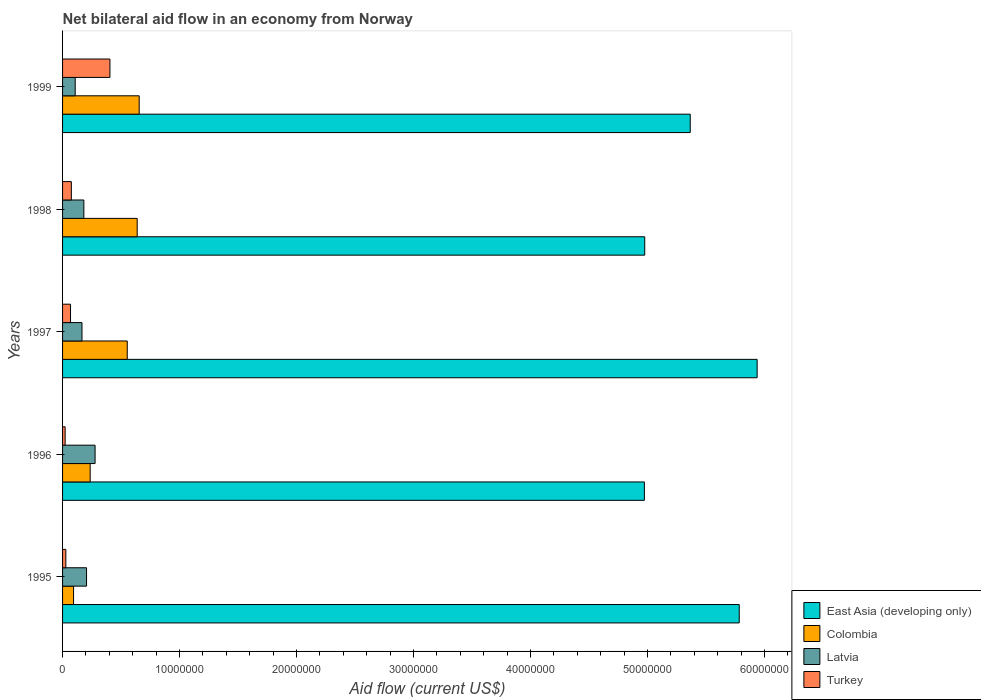How many groups of bars are there?
Make the answer very short. 5. What is the label of the 3rd group of bars from the top?
Provide a short and direct response. 1997. Across all years, what is the maximum net bilateral aid flow in Latvia?
Offer a terse response. 2.78e+06. Across all years, what is the minimum net bilateral aid flow in East Asia (developing only)?
Give a very brief answer. 4.97e+07. In which year was the net bilateral aid flow in Turkey minimum?
Your answer should be very brief. 1996. What is the total net bilateral aid flow in Latvia in the graph?
Your answer should be very brief. 9.39e+06. What is the difference between the net bilateral aid flow in East Asia (developing only) in 1998 and that in 1999?
Offer a very short reply. -3.89e+06. What is the difference between the net bilateral aid flow in Latvia in 1996 and the net bilateral aid flow in Turkey in 1999?
Your answer should be very brief. -1.27e+06. What is the average net bilateral aid flow in Colombia per year?
Provide a succinct answer. 4.35e+06. In the year 1996, what is the difference between the net bilateral aid flow in East Asia (developing only) and net bilateral aid flow in Turkey?
Offer a terse response. 4.95e+07. What is the ratio of the net bilateral aid flow in Latvia in 1996 to that in 1998?
Offer a terse response. 1.53. Is the net bilateral aid flow in Colombia in 1996 less than that in 1997?
Provide a short and direct response. Yes. What is the difference between the highest and the second highest net bilateral aid flow in Colombia?
Provide a short and direct response. 1.70e+05. What is the difference between the highest and the lowest net bilateral aid flow in Colombia?
Offer a terse response. 5.61e+06. In how many years, is the net bilateral aid flow in Colombia greater than the average net bilateral aid flow in Colombia taken over all years?
Offer a terse response. 3. Is it the case that in every year, the sum of the net bilateral aid flow in East Asia (developing only) and net bilateral aid flow in Latvia is greater than the sum of net bilateral aid flow in Turkey and net bilateral aid flow in Colombia?
Give a very brief answer. Yes. What does the 4th bar from the bottom in 1997 represents?
Your answer should be compact. Turkey. How many bars are there?
Your answer should be very brief. 20. What is the difference between two consecutive major ticks on the X-axis?
Ensure brevity in your answer.  1.00e+07. Does the graph contain grids?
Offer a very short reply. No. Where does the legend appear in the graph?
Your answer should be very brief. Bottom right. How are the legend labels stacked?
Your answer should be compact. Vertical. What is the title of the graph?
Your answer should be compact. Net bilateral aid flow in an economy from Norway. Does "United Kingdom" appear as one of the legend labels in the graph?
Provide a short and direct response. No. What is the label or title of the X-axis?
Provide a short and direct response. Aid flow (current US$). What is the Aid flow (current US$) in East Asia (developing only) in 1995?
Give a very brief answer. 5.78e+07. What is the Aid flow (current US$) in Colombia in 1995?
Ensure brevity in your answer.  9.40e+05. What is the Aid flow (current US$) of Latvia in 1995?
Keep it short and to the point. 2.05e+06. What is the Aid flow (current US$) of Turkey in 1995?
Provide a succinct answer. 2.80e+05. What is the Aid flow (current US$) in East Asia (developing only) in 1996?
Offer a very short reply. 4.97e+07. What is the Aid flow (current US$) of Colombia in 1996?
Your answer should be very brief. 2.36e+06. What is the Aid flow (current US$) of Latvia in 1996?
Offer a terse response. 2.78e+06. What is the Aid flow (current US$) in Turkey in 1996?
Your answer should be compact. 2.20e+05. What is the Aid flow (current US$) of East Asia (developing only) in 1997?
Offer a terse response. 5.94e+07. What is the Aid flow (current US$) of Colombia in 1997?
Your answer should be very brief. 5.53e+06. What is the Aid flow (current US$) of Latvia in 1997?
Offer a very short reply. 1.66e+06. What is the Aid flow (current US$) in Turkey in 1997?
Offer a terse response. 6.80e+05. What is the Aid flow (current US$) of East Asia (developing only) in 1998?
Keep it short and to the point. 4.98e+07. What is the Aid flow (current US$) in Colombia in 1998?
Ensure brevity in your answer.  6.38e+06. What is the Aid flow (current US$) in Latvia in 1998?
Your answer should be very brief. 1.82e+06. What is the Aid flow (current US$) in Turkey in 1998?
Give a very brief answer. 7.50e+05. What is the Aid flow (current US$) in East Asia (developing only) in 1999?
Offer a terse response. 5.37e+07. What is the Aid flow (current US$) of Colombia in 1999?
Provide a short and direct response. 6.55e+06. What is the Aid flow (current US$) of Latvia in 1999?
Offer a terse response. 1.08e+06. What is the Aid flow (current US$) in Turkey in 1999?
Your answer should be very brief. 4.05e+06. Across all years, what is the maximum Aid flow (current US$) of East Asia (developing only)?
Provide a succinct answer. 5.94e+07. Across all years, what is the maximum Aid flow (current US$) in Colombia?
Offer a very short reply. 6.55e+06. Across all years, what is the maximum Aid flow (current US$) in Latvia?
Your response must be concise. 2.78e+06. Across all years, what is the maximum Aid flow (current US$) in Turkey?
Give a very brief answer. 4.05e+06. Across all years, what is the minimum Aid flow (current US$) in East Asia (developing only)?
Give a very brief answer. 4.97e+07. Across all years, what is the minimum Aid flow (current US$) of Colombia?
Offer a terse response. 9.40e+05. Across all years, what is the minimum Aid flow (current US$) in Latvia?
Provide a succinct answer. 1.08e+06. What is the total Aid flow (current US$) in East Asia (developing only) in the graph?
Offer a terse response. 2.70e+08. What is the total Aid flow (current US$) in Colombia in the graph?
Give a very brief answer. 2.18e+07. What is the total Aid flow (current US$) of Latvia in the graph?
Provide a short and direct response. 9.39e+06. What is the total Aid flow (current US$) in Turkey in the graph?
Offer a terse response. 5.98e+06. What is the difference between the Aid flow (current US$) in East Asia (developing only) in 1995 and that in 1996?
Your answer should be compact. 8.11e+06. What is the difference between the Aid flow (current US$) in Colombia in 1995 and that in 1996?
Offer a very short reply. -1.42e+06. What is the difference between the Aid flow (current US$) in Latvia in 1995 and that in 1996?
Provide a short and direct response. -7.30e+05. What is the difference between the Aid flow (current US$) in Turkey in 1995 and that in 1996?
Offer a very short reply. 6.00e+04. What is the difference between the Aid flow (current US$) of East Asia (developing only) in 1995 and that in 1997?
Offer a very short reply. -1.53e+06. What is the difference between the Aid flow (current US$) in Colombia in 1995 and that in 1997?
Your response must be concise. -4.59e+06. What is the difference between the Aid flow (current US$) of Turkey in 1995 and that in 1997?
Provide a short and direct response. -4.00e+05. What is the difference between the Aid flow (current US$) in East Asia (developing only) in 1995 and that in 1998?
Provide a succinct answer. 8.08e+06. What is the difference between the Aid flow (current US$) in Colombia in 1995 and that in 1998?
Keep it short and to the point. -5.44e+06. What is the difference between the Aid flow (current US$) of Turkey in 1995 and that in 1998?
Ensure brevity in your answer.  -4.70e+05. What is the difference between the Aid flow (current US$) in East Asia (developing only) in 1995 and that in 1999?
Your response must be concise. 4.19e+06. What is the difference between the Aid flow (current US$) in Colombia in 1995 and that in 1999?
Your response must be concise. -5.61e+06. What is the difference between the Aid flow (current US$) of Latvia in 1995 and that in 1999?
Your answer should be very brief. 9.70e+05. What is the difference between the Aid flow (current US$) of Turkey in 1995 and that in 1999?
Your response must be concise. -3.77e+06. What is the difference between the Aid flow (current US$) of East Asia (developing only) in 1996 and that in 1997?
Your answer should be compact. -9.64e+06. What is the difference between the Aid flow (current US$) of Colombia in 1996 and that in 1997?
Your answer should be very brief. -3.17e+06. What is the difference between the Aid flow (current US$) of Latvia in 1996 and that in 1997?
Keep it short and to the point. 1.12e+06. What is the difference between the Aid flow (current US$) in Turkey in 1996 and that in 1997?
Your response must be concise. -4.60e+05. What is the difference between the Aid flow (current US$) in East Asia (developing only) in 1996 and that in 1998?
Keep it short and to the point. -3.00e+04. What is the difference between the Aid flow (current US$) in Colombia in 1996 and that in 1998?
Make the answer very short. -4.02e+06. What is the difference between the Aid flow (current US$) in Latvia in 1996 and that in 1998?
Offer a terse response. 9.60e+05. What is the difference between the Aid flow (current US$) in Turkey in 1996 and that in 1998?
Provide a short and direct response. -5.30e+05. What is the difference between the Aid flow (current US$) in East Asia (developing only) in 1996 and that in 1999?
Offer a very short reply. -3.92e+06. What is the difference between the Aid flow (current US$) in Colombia in 1996 and that in 1999?
Offer a very short reply. -4.19e+06. What is the difference between the Aid flow (current US$) in Latvia in 1996 and that in 1999?
Your answer should be compact. 1.70e+06. What is the difference between the Aid flow (current US$) in Turkey in 1996 and that in 1999?
Offer a very short reply. -3.83e+06. What is the difference between the Aid flow (current US$) of East Asia (developing only) in 1997 and that in 1998?
Your response must be concise. 9.61e+06. What is the difference between the Aid flow (current US$) of Colombia in 1997 and that in 1998?
Keep it short and to the point. -8.50e+05. What is the difference between the Aid flow (current US$) in Latvia in 1997 and that in 1998?
Your answer should be compact. -1.60e+05. What is the difference between the Aid flow (current US$) of Turkey in 1997 and that in 1998?
Provide a succinct answer. -7.00e+04. What is the difference between the Aid flow (current US$) of East Asia (developing only) in 1997 and that in 1999?
Provide a short and direct response. 5.72e+06. What is the difference between the Aid flow (current US$) of Colombia in 1997 and that in 1999?
Make the answer very short. -1.02e+06. What is the difference between the Aid flow (current US$) in Latvia in 1997 and that in 1999?
Your response must be concise. 5.80e+05. What is the difference between the Aid flow (current US$) in Turkey in 1997 and that in 1999?
Offer a very short reply. -3.37e+06. What is the difference between the Aid flow (current US$) of East Asia (developing only) in 1998 and that in 1999?
Offer a very short reply. -3.89e+06. What is the difference between the Aid flow (current US$) in Latvia in 1998 and that in 1999?
Provide a succinct answer. 7.40e+05. What is the difference between the Aid flow (current US$) of Turkey in 1998 and that in 1999?
Your answer should be compact. -3.30e+06. What is the difference between the Aid flow (current US$) of East Asia (developing only) in 1995 and the Aid flow (current US$) of Colombia in 1996?
Make the answer very short. 5.55e+07. What is the difference between the Aid flow (current US$) in East Asia (developing only) in 1995 and the Aid flow (current US$) in Latvia in 1996?
Offer a very short reply. 5.51e+07. What is the difference between the Aid flow (current US$) of East Asia (developing only) in 1995 and the Aid flow (current US$) of Turkey in 1996?
Ensure brevity in your answer.  5.76e+07. What is the difference between the Aid flow (current US$) of Colombia in 1995 and the Aid flow (current US$) of Latvia in 1996?
Offer a terse response. -1.84e+06. What is the difference between the Aid flow (current US$) in Colombia in 1995 and the Aid flow (current US$) in Turkey in 1996?
Keep it short and to the point. 7.20e+05. What is the difference between the Aid flow (current US$) in Latvia in 1995 and the Aid flow (current US$) in Turkey in 1996?
Give a very brief answer. 1.83e+06. What is the difference between the Aid flow (current US$) in East Asia (developing only) in 1995 and the Aid flow (current US$) in Colombia in 1997?
Your answer should be compact. 5.23e+07. What is the difference between the Aid flow (current US$) in East Asia (developing only) in 1995 and the Aid flow (current US$) in Latvia in 1997?
Your answer should be very brief. 5.62e+07. What is the difference between the Aid flow (current US$) of East Asia (developing only) in 1995 and the Aid flow (current US$) of Turkey in 1997?
Give a very brief answer. 5.72e+07. What is the difference between the Aid flow (current US$) of Colombia in 1995 and the Aid flow (current US$) of Latvia in 1997?
Your answer should be compact. -7.20e+05. What is the difference between the Aid flow (current US$) of Colombia in 1995 and the Aid flow (current US$) of Turkey in 1997?
Give a very brief answer. 2.60e+05. What is the difference between the Aid flow (current US$) in Latvia in 1995 and the Aid flow (current US$) in Turkey in 1997?
Your response must be concise. 1.37e+06. What is the difference between the Aid flow (current US$) in East Asia (developing only) in 1995 and the Aid flow (current US$) in Colombia in 1998?
Offer a very short reply. 5.15e+07. What is the difference between the Aid flow (current US$) of East Asia (developing only) in 1995 and the Aid flow (current US$) of Latvia in 1998?
Your response must be concise. 5.60e+07. What is the difference between the Aid flow (current US$) in East Asia (developing only) in 1995 and the Aid flow (current US$) in Turkey in 1998?
Offer a very short reply. 5.71e+07. What is the difference between the Aid flow (current US$) of Colombia in 1995 and the Aid flow (current US$) of Latvia in 1998?
Make the answer very short. -8.80e+05. What is the difference between the Aid flow (current US$) of Latvia in 1995 and the Aid flow (current US$) of Turkey in 1998?
Make the answer very short. 1.30e+06. What is the difference between the Aid flow (current US$) in East Asia (developing only) in 1995 and the Aid flow (current US$) in Colombia in 1999?
Provide a succinct answer. 5.13e+07. What is the difference between the Aid flow (current US$) of East Asia (developing only) in 1995 and the Aid flow (current US$) of Latvia in 1999?
Your answer should be very brief. 5.68e+07. What is the difference between the Aid flow (current US$) of East Asia (developing only) in 1995 and the Aid flow (current US$) of Turkey in 1999?
Make the answer very short. 5.38e+07. What is the difference between the Aid flow (current US$) in Colombia in 1995 and the Aid flow (current US$) in Turkey in 1999?
Keep it short and to the point. -3.11e+06. What is the difference between the Aid flow (current US$) of East Asia (developing only) in 1996 and the Aid flow (current US$) of Colombia in 1997?
Your answer should be compact. 4.42e+07. What is the difference between the Aid flow (current US$) of East Asia (developing only) in 1996 and the Aid flow (current US$) of Latvia in 1997?
Keep it short and to the point. 4.81e+07. What is the difference between the Aid flow (current US$) of East Asia (developing only) in 1996 and the Aid flow (current US$) of Turkey in 1997?
Provide a succinct answer. 4.91e+07. What is the difference between the Aid flow (current US$) of Colombia in 1996 and the Aid flow (current US$) of Latvia in 1997?
Provide a short and direct response. 7.00e+05. What is the difference between the Aid flow (current US$) in Colombia in 1996 and the Aid flow (current US$) in Turkey in 1997?
Keep it short and to the point. 1.68e+06. What is the difference between the Aid flow (current US$) in Latvia in 1996 and the Aid flow (current US$) in Turkey in 1997?
Ensure brevity in your answer.  2.10e+06. What is the difference between the Aid flow (current US$) in East Asia (developing only) in 1996 and the Aid flow (current US$) in Colombia in 1998?
Ensure brevity in your answer.  4.34e+07. What is the difference between the Aid flow (current US$) in East Asia (developing only) in 1996 and the Aid flow (current US$) in Latvia in 1998?
Ensure brevity in your answer.  4.79e+07. What is the difference between the Aid flow (current US$) in East Asia (developing only) in 1996 and the Aid flow (current US$) in Turkey in 1998?
Your answer should be very brief. 4.90e+07. What is the difference between the Aid flow (current US$) in Colombia in 1996 and the Aid flow (current US$) in Latvia in 1998?
Make the answer very short. 5.40e+05. What is the difference between the Aid flow (current US$) of Colombia in 1996 and the Aid flow (current US$) of Turkey in 1998?
Provide a short and direct response. 1.61e+06. What is the difference between the Aid flow (current US$) in Latvia in 1996 and the Aid flow (current US$) in Turkey in 1998?
Provide a succinct answer. 2.03e+06. What is the difference between the Aid flow (current US$) of East Asia (developing only) in 1996 and the Aid flow (current US$) of Colombia in 1999?
Your answer should be very brief. 4.32e+07. What is the difference between the Aid flow (current US$) in East Asia (developing only) in 1996 and the Aid flow (current US$) in Latvia in 1999?
Keep it short and to the point. 4.87e+07. What is the difference between the Aid flow (current US$) of East Asia (developing only) in 1996 and the Aid flow (current US$) of Turkey in 1999?
Give a very brief answer. 4.57e+07. What is the difference between the Aid flow (current US$) of Colombia in 1996 and the Aid flow (current US$) of Latvia in 1999?
Ensure brevity in your answer.  1.28e+06. What is the difference between the Aid flow (current US$) in Colombia in 1996 and the Aid flow (current US$) in Turkey in 1999?
Keep it short and to the point. -1.69e+06. What is the difference between the Aid flow (current US$) in Latvia in 1996 and the Aid flow (current US$) in Turkey in 1999?
Your answer should be compact. -1.27e+06. What is the difference between the Aid flow (current US$) in East Asia (developing only) in 1997 and the Aid flow (current US$) in Colombia in 1998?
Give a very brief answer. 5.30e+07. What is the difference between the Aid flow (current US$) of East Asia (developing only) in 1997 and the Aid flow (current US$) of Latvia in 1998?
Offer a terse response. 5.76e+07. What is the difference between the Aid flow (current US$) in East Asia (developing only) in 1997 and the Aid flow (current US$) in Turkey in 1998?
Your answer should be very brief. 5.86e+07. What is the difference between the Aid flow (current US$) in Colombia in 1997 and the Aid flow (current US$) in Latvia in 1998?
Offer a very short reply. 3.71e+06. What is the difference between the Aid flow (current US$) of Colombia in 1997 and the Aid flow (current US$) of Turkey in 1998?
Make the answer very short. 4.78e+06. What is the difference between the Aid flow (current US$) of Latvia in 1997 and the Aid flow (current US$) of Turkey in 1998?
Ensure brevity in your answer.  9.10e+05. What is the difference between the Aid flow (current US$) of East Asia (developing only) in 1997 and the Aid flow (current US$) of Colombia in 1999?
Keep it short and to the point. 5.28e+07. What is the difference between the Aid flow (current US$) of East Asia (developing only) in 1997 and the Aid flow (current US$) of Latvia in 1999?
Your response must be concise. 5.83e+07. What is the difference between the Aid flow (current US$) of East Asia (developing only) in 1997 and the Aid flow (current US$) of Turkey in 1999?
Your answer should be very brief. 5.53e+07. What is the difference between the Aid flow (current US$) of Colombia in 1997 and the Aid flow (current US$) of Latvia in 1999?
Provide a succinct answer. 4.45e+06. What is the difference between the Aid flow (current US$) in Colombia in 1997 and the Aid flow (current US$) in Turkey in 1999?
Provide a short and direct response. 1.48e+06. What is the difference between the Aid flow (current US$) of Latvia in 1997 and the Aid flow (current US$) of Turkey in 1999?
Provide a short and direct response. -2.39e+06. What is the difference between the Aid flow (current US$) in East Asia (developing only) in 1998 and the Aid flow (current US$) in Colombia in 1999?
Your response must be concise. 4.32e+07. What is the difference between the Aid flow (current US$) in East Asia (developing only) in 1998 and the Aid flow (current US$) in Latvia in 1999?
Your response must be concise. 4.87e+07. What is the difference between the Aid flow (current US$) in East Asia (developing only) in 1998 and the Aid flow (current US$) in Turkey in 1999?
Make the answer very short. 4.57e+07. What is the difference between the Aid flow (current US$) of Colombia in 1998 and the Aid flow (current US$) of Latvia in 1999?
Make the answer very short. 5.30e+06. What is the difference between the Aid flow (current US$) in Colombia in 1998 and the Aid flow (current US$) in Turkey in 1999?
Offer a terse response. 2.33e+06. What is the difference between the Aid flow (current US$) in Latvia in 1998 and the Aid flow (current US$) in Turkey in 1999?
Give a very brief answer. -2.23e+06. What is the average Aid flow (current US$) in East Asia (developing only) per year?
Your answer should be very brief. 5.41e+07. What is the average Aid flow (current US$) of Colombia per year?
Your answer should be compact. 4.35e+06. What is the average Aid flow (current US$) of Latvia per year?
Keep it short and to the point. 1.88e+06. What is the average Aid flow (current US$) of Turkey per year?
Provide a short and direct response. 1.20e+06. In the year 1995, what is the difference between the Aid flow (current US$) of East Asia (developing only) and Aid flow (current US$) of Colombia?
Your answer should be compact. 5.69e+07. In the year 1995, what is the difference between the Aid flow (current US$) of East Asia (developing only) and Aid flow (current US$) of Latvia?
Your answer should be very brief. 5.58e+07. In the year 1995, what is the difference between the Aid flow (current US$) of East Asia (developing only) and Aid flow (current US$) of Turkey?
Your answer should be very brief. 5.76e+07. In the year 1995, what is the difference between the Aid flow (current US$) of Colombia and Aid flow (current US$) of Latvia?
Your answer should be very brief. -1.11e+06. In the year 1995, what is the difference between the Aid flow (current US$) of Colombia and Aid flow (current US$) of Turkey?
Your answer should be compact. 6.60e+05. In the year 1995, what is the difference between the Aid flow (current US$) in Latvia and Aid flow (current US$) in Turkey?
Keep it short and to the point. 1.77e+06. In the year 1996, what is the difference between the Aid flow (current US$) of East Asia (developing only) and Aid flow (current US$) of Colombia?
Your response must be concise. 4.74e+07. In the year 1996, what is the difference between the Aid flow (current US$) of East Asia (developing only) and Aid flow (current US$) of Latvia?
Provide a succinct answer. 4.70e+07. In the year 1996, what is the difference between the Aid flow (current US$) of East Asia (developing only) and Aid flow (current US$) of Turkey?
Keep it short and to the point. 4.95e+07. In the year 1996, what is the difference between the Aid flow (current US$) in Colombia and Aid flow (current US$) in Latvia?
Your answer should be very brief. -4.20e+05. In the year 1996, what is the difference between the Aid flow (current US$) in Colombia and Aid flow (current US$) in Turkey?
Make the answer very short. 2.14e+06. In the year 1996, what is the difference between the Aid flow (current US$) of Latvia and Aid flow (current US$) of Turkey?
Your answer should be very brief. 2.56e+06. In the year 1997, what is the difference between the Aid flow (current US$) of East Asia (developing only) and Aid flow (current US$) of Colombia?
Ensure brevity in your answer.  5.38e+07. In the year 1997, what is the difference between the Aid flow (current US$) in East Asia (developing only) and Aid flow (current US$) in Latvia?
Provide a succinct answer. 5.77e+07. In the year 1997, what is the difference between the Aid flow (current US$) in East Asia (developing only) and Aid flow (current US$) in Turkey?
Give a very brief answer. 5.87e+07. In the year 1997, what is the difference between the Aid flow (current US$) of Colombia and Aid flow (current US$) of Latvia?
Make the answer very short. 3.87e+06. In the year 1997, what is the difference between the Aid flow (current US$) in Colombia and Aid flow (current US$) in Turkey?
Make the answer very short. 4.85e+06. In the year 1997, what is the difference between the Aid flow (current US$) of Latvia and Aid flow (current US$) of Turkey?
Offer a terse response. 9.80e+05. In the year 1998, what is the difference between the Aid flow (current US$) of East Asia (developing only) and Aid flow (current US$) of Colombia?
Ensure brevity in your answer.  4.34e+07. In the year 1998, what is the difference between the Aid flow (current US$) of East Asia (developing only) and Aid flow (current US$) of Latvia?
Make the answer very short. 4.80e+07. In the year 1998, what is the difference between the Aid flow (current US$) in East Asia (developing only) and Aid flow (current US$) in Turkey?
Your response must be concise. 4.90e+07. In the year 1998, what is the difference between the Aid flow (current US$) of Colombia and Aid flow (current US$) of Latvia?
Offer a terse response. 4.56e+06. In the year 1998, what is the difference between the Aid flow (current US$) in Colombia and Aid flow (current US$) in Turkey?
Make the answer very short. 5.63e+06. In the year 1998, what is the difference between the Aid flow (current US$) in Latvia and Aid flow (current US$) in Turkey?
Give a very brief answer. 1.07e+06. In the year 1999, what is the difference between the Aid flow (current US$) of East Asia (developing only) and Aid flow (current US$) of Colombia?
Your response must be concise. 4.71e+07. In the year 1999, what is the difference between the Aid flow (current US$) of East Asia (developing only) and Aid flow (current US$) of Latvia?
Give a very brief answer. 5.26e+07. In the year 1999, what is the difference between the Aid flow (current US$) of East Asia (developing only) and Aid flow (current US$) of Turkey?
Your answer should be very brief. 4.96e+07. In the year 1999, what is the difference between the Aid flow (current US$) of Colombia and Aid flow (current US$) of Latvia?
Give a very brief answer. 5.47e+06. In the year 1999, what is the difference between the Aid flow (current US$) of Colombia and Aid flow (current US$) of Turkey?
Your response must be concise. 2.50e+06. In the year 1999, what is the difference between the Aid flow (current US$) in Latvia and Aid flow (current US$) in Turkey?
Offer a terse response. -2.97e+06. What is the ratio of the Aid flow (current US$) of East Asia (developing only) in 1995 to that in 1996?
Provide a succinct answer. 1.16. What is the ratio of the Aid flow (current US$) in Colombia in 1995 to that in 1996?
Offer a terse response. 0.4. What is the ratio of the Aid flow (current US$) in Latvia in 1995 to that in 1996?
Your answer should be compact. 0.74. What is the ratio of the Aid flow (current US$) in Turkey in 1995 to that in 1996?
Make the answer very short. 1.27. What is the ratio of the Aid flow (current US$) in East Asia (developing only) in 1995 to that in 1997?
Provide a succinct answer. 0.97. What is the ratio of the Aid flow (current US$) in Colombia in 1995 to that in 1997?
Your answer should be compact. 0.17. What is the ratio of the Aid flow (current US$) of Latvia in 1995 to that in 1997?
Your answer should be compact. 1.23. What is the ratio of the Aid flow (current US$) of Turkey in 1995 to that in 1997?
Your answer should be compact. 0.41. What is the ratio of the Aid flow (current US$) in East Asia (developing only) in 1995 to that in 1998?
Offer a very short reply. 1.16. What is the ratio of the Aid flow (current US$) of Colombia in 1995 to that in 1998?
Provide a succinct answer. 0.15. What is the ratio of the Aid flow (current US$) in Latvia in 1995 to that in 1998?
Give a very brief answer. 1.13. What is the ratio of the Aid flow (current US$) in Turkey in 1995 to that in 1998?
Provide a succinct answer. 0.37. What is the ratio of the Aid flow (current US$) of East Asia (developing only) in 1995 to that in 1999?
Provide a succinct answer. 1.08. What is the ratio of the Aid flow (current US$) of Colombia in 1995 to that in 1999?
Provide a short and direct response. 0.14. What is the ratio of the Aid flow (current US$) in Latvia in 1995 to that in 1999?
Provide a succinct answer. 1.9. What is the ratio of the Aid flow (current US$) in Turkey in 1995 to that in 1999?
Your response must be concise. 0.07. What is the ratio of the Aid flow (current US$) of East Asia (developing only) in 1996 to that in 1997?
Offer a very short reply. 0.84. What is the ratio of the Aid flow (current US$) of Colombia in 1996 to that in 1997?
Ensure brevity in your answer.  0.43. What is the ratio of the Aid flow (current US$) of Latvia in 1996 to that in 1997?
Provide a succinct answer. 1.67. What is the ratio of the Aid flow (current US$) of Turkey in 1996 to that in 1997?
Ensure brevity in your answer.  0.32. What is the ratio of the Aid flow (current US$) of East Asia (developing only) in 1996 to that in 1998?
Make the answer very short. 1. What is the ratio of the Aid flow (current US$) in Colombia in 1996 to that in 1998?
Make the answer very short. 0.37. What is the ratio of the Aid flow (current US$) of Latvia in 1996 to that in 1998?
Keep it short and to the point. 1.53. What is the ratio of the Aid flow (current US$) in Turkey in 1996 to that in 1998?
Offer a very short reply. 0.29. What is the ratio of the Aid flow (current US$) in East Asia (developing only) in 1996 to that in 1999?
Your answer should be compact. 0.93. What is the ratio of the Aid flow (current US$) of Colombia in 1996 to that in 1999?
Your response must be concise. 0.36. What is the ratio of the Aid flow (current US$) of Latvia in 1996 to that in 1999?
Offer a terse response. 2.57. What is the ratio of the Aid flow (current US$) in Turkey in 1996 to that in 1999?
Keep it short and to the point. 0.05. What is the ratio of the Aid flow (current US$) in East Asia (developing only) in 1997 to that in 1998?
Your answer should be very brief. 1.19. What is the ratio of the Aid flow (current US$) of Colombia in 1997 to that in 1998?
Your response must be concise. 0.87. What is the ratio of the Aid flow (current US$) in Latvia in 1997 to that in 1998?
Provide a succinct answer. 0.91. What is the ratio of the Aid flow (current US$) of Turkey in 1997 to that in 1998?
Give a very brief answer. 0.91. What is the ratio of the Aid flow (current US$) in East Asia (developing only) in 1997 to that in 1999?
Ensure brevity in your answer.  1.11. What is the ratio of the Aid flow (current US$) in Colombia in 1997 to that in 1999?
Give a very brief answer. 0.84. What is the ratio of the Aid flow (current US$) in Latvia in 1997 to that in 1999?
Offer a very short reply. 1.54. What is the ratio of the Aid flow (current US$) of Turkey in 1997 to that in 1999?
Offer a terse response. 0.17. What is the ratio of the Aid flow (current US$) in East Asia (developing only) in 1998 to that in 1999?
Your answer should be compact. 0.93. What is the ratio of the Aid flow (current US$) of Colombia in 1998 to that in 1999?
Your answer should be compact. 0.97. What is the ratio of the Aid flow (current US$) in Latvia in 1998 to that in 1999?
Your answer should be compact. 1.69. What is the ratio of the Aid flow (current US$) of Turkey in 1998 to that in 1999?
Offer a very short reply. 0.19. What is the difference between the highest and the second highest Aid flow (current US$) of East Asia (developing only)?
Offer a very short reply. 1.53e+06. What is the difference between the highest and the second highest Aid flow (current US$) of Latvia?
Give a very brief answer. 7.30e+05. What is the difference between the highest and the second highest Aid flow (current US$) of Turkey?
Give a very brief answer. 3.30e+06. What is the difference between the highest and the lowest Aid flow (current US$) of East Asia (developing only)?
Provide a short and direct response. 9.64e+06. What is the difference between the highest and the lowest Aid flow (current US$) of Colombia?
Your response must be concise. 5.61e+06. What is the difference between the highest and the lowest Aid flow (current US$) of Latvia?
Give a very brief answer. 1.70e+06. What is the difference between the highest and the lowest Aid flow (current US$) in Turkey?
Make the answer very short. 3.83e+06. 